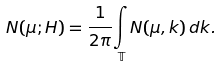Convert formula to latex. <formula><loc_0><loc_0><loc_500><loc_500>N ( \mu ; H ) = \frac { 1 } { 2 \pi } \underset { \mathbb { T } } \int N ( \mu , k ) \, d k .</formula> 